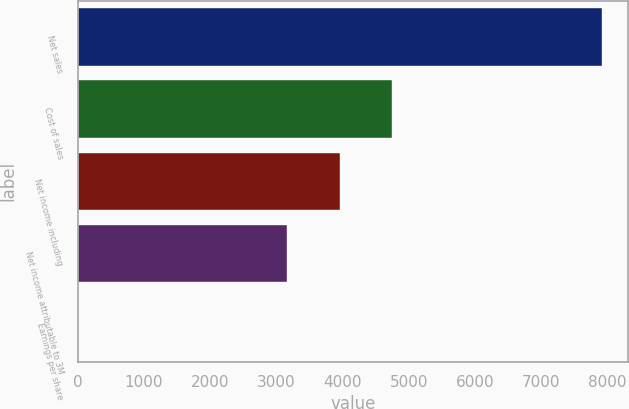Convert chart to OTSL. <chart><loc_0><loc_0><loc_500><loc_500><bar_chart><fcel>Net sales<fcel>Cost of sales<fcel>Net income including<fcel>Net income attributable to 3M<fcel>Earnings per share<nl><fcel>7916<fcel>4750.28<fcel>3958.84<fcel>3167.4<fcel>1.65<nl></chart> 